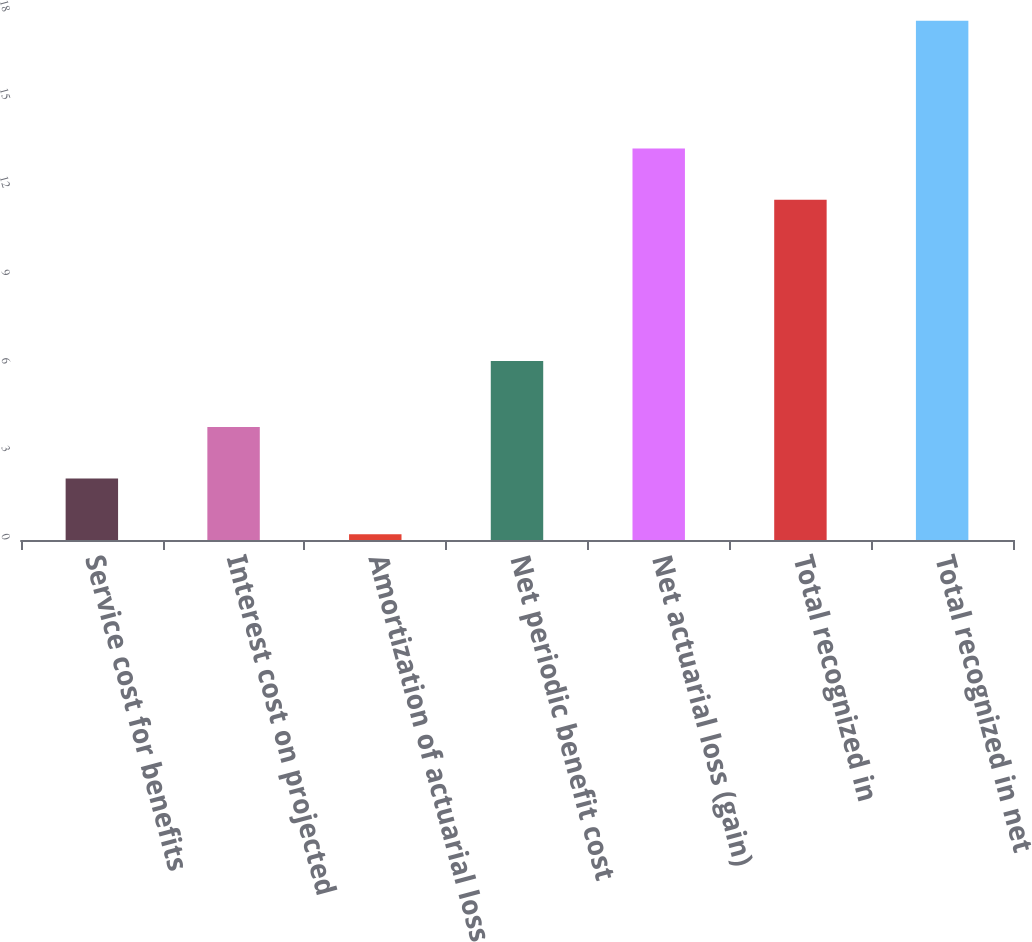Convert chart. <chart><loc_0><loc_0><loc_500><loc_500><bar_chart><fcel>Service cost for benefits<fcel>Interest cost on projected<fcel>Amortization of actuarial loss<fcel>Net periodic benefit cost<fcel>Net actuarial loss (gain)<fcel>Total recognized in<fcel>Total recognized in net<nl><fcel>2.1<fcel>3.85<fcel>0.2<fcel>6.1<fcel>13.35<fcel>11.6<fcel>17.7<nl></chart> 